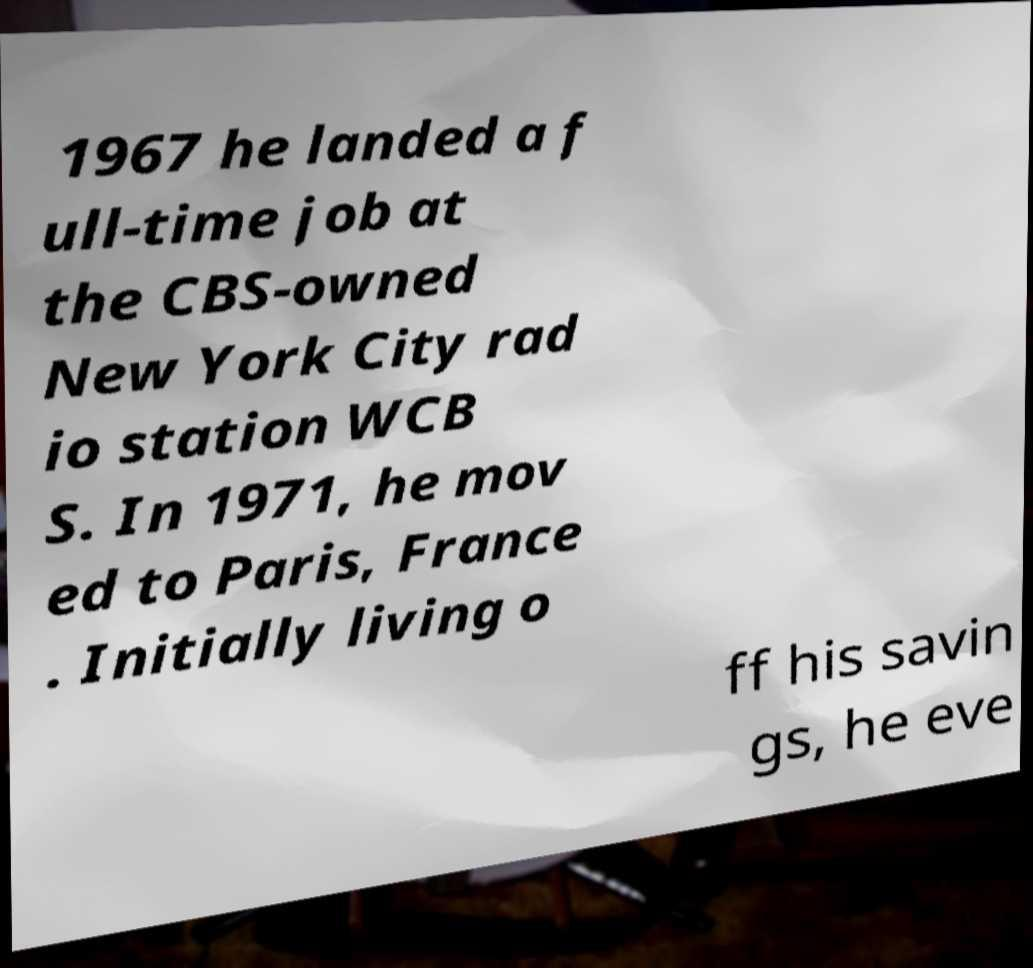For documentation purposes, I need the text within this image transcribed. Could you provide that? 1967 he landed a f ull-time job at the CBS-owned New York City rad io station WCB S. In 1971, he mov ed to Paris, France . Initially living o ff his savin gs, he eve 